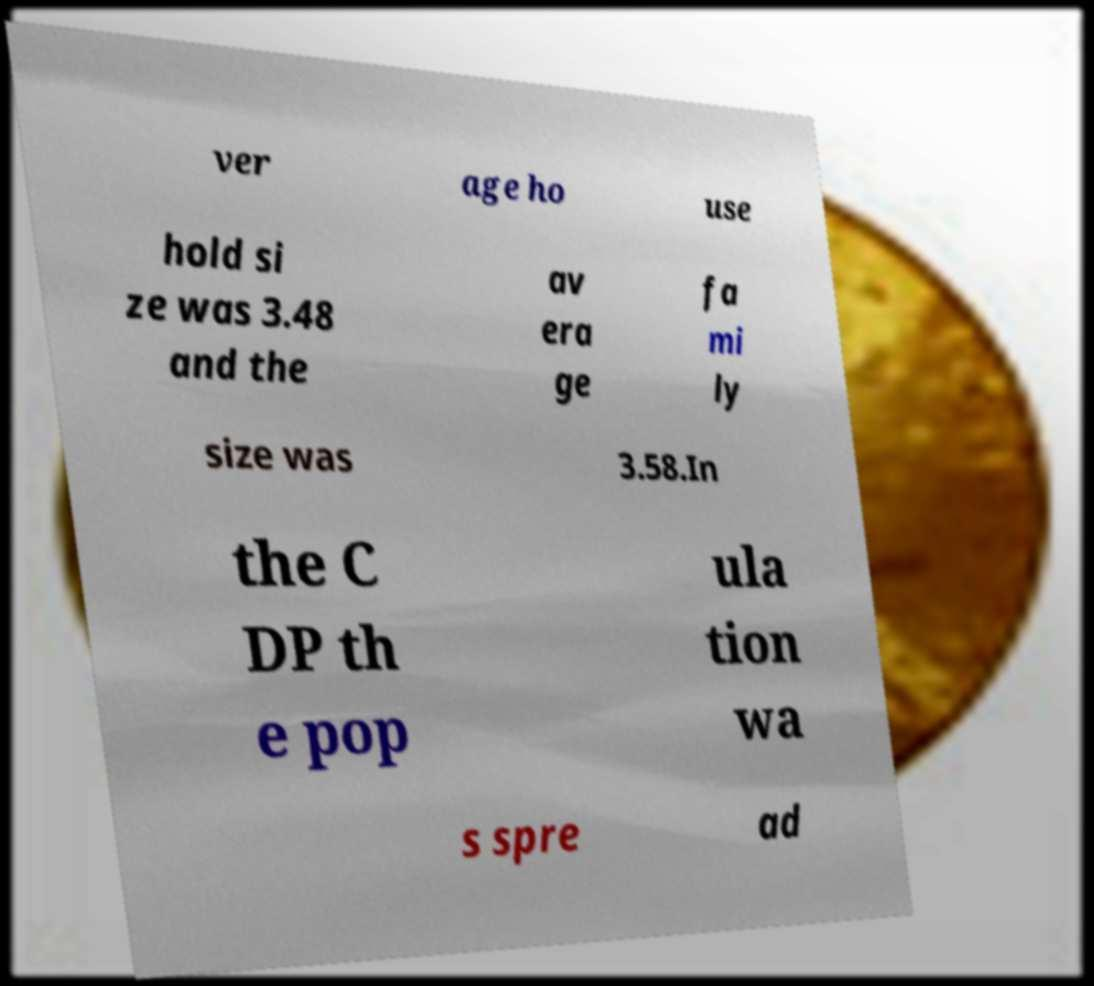Can you accurately transcribe the text from the provided image for me? ver age ho use hold si ze was 3.48 and the av era ge fa mi ly size was 3.58.In the C DP th e pop ula tion wa s spre ad 